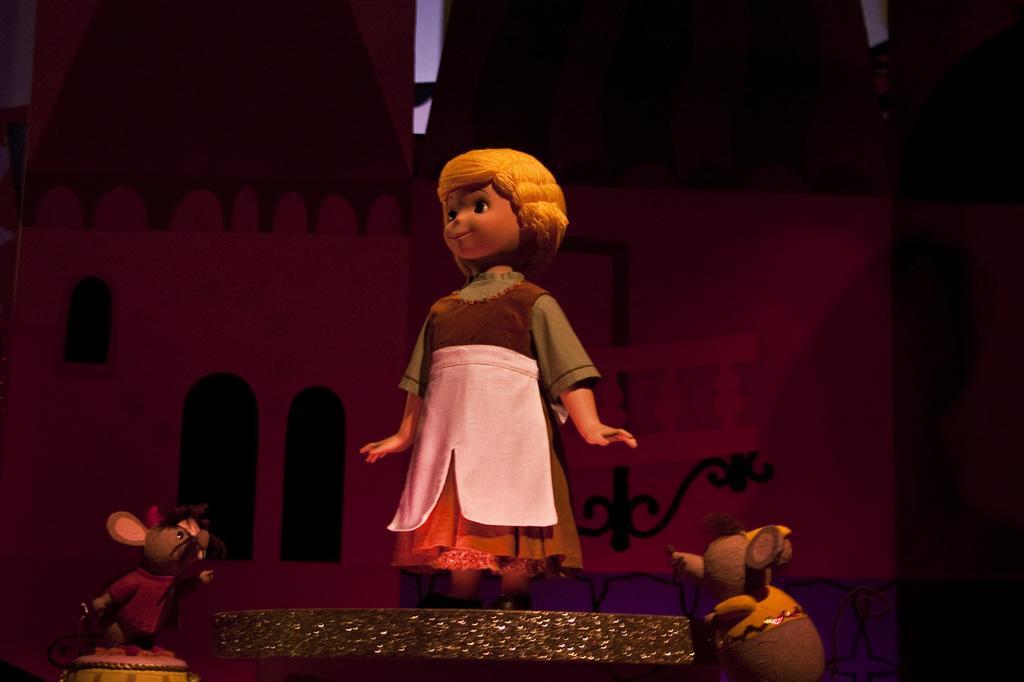Can you describe this image briefly? There are dolls presenting in this picture. 